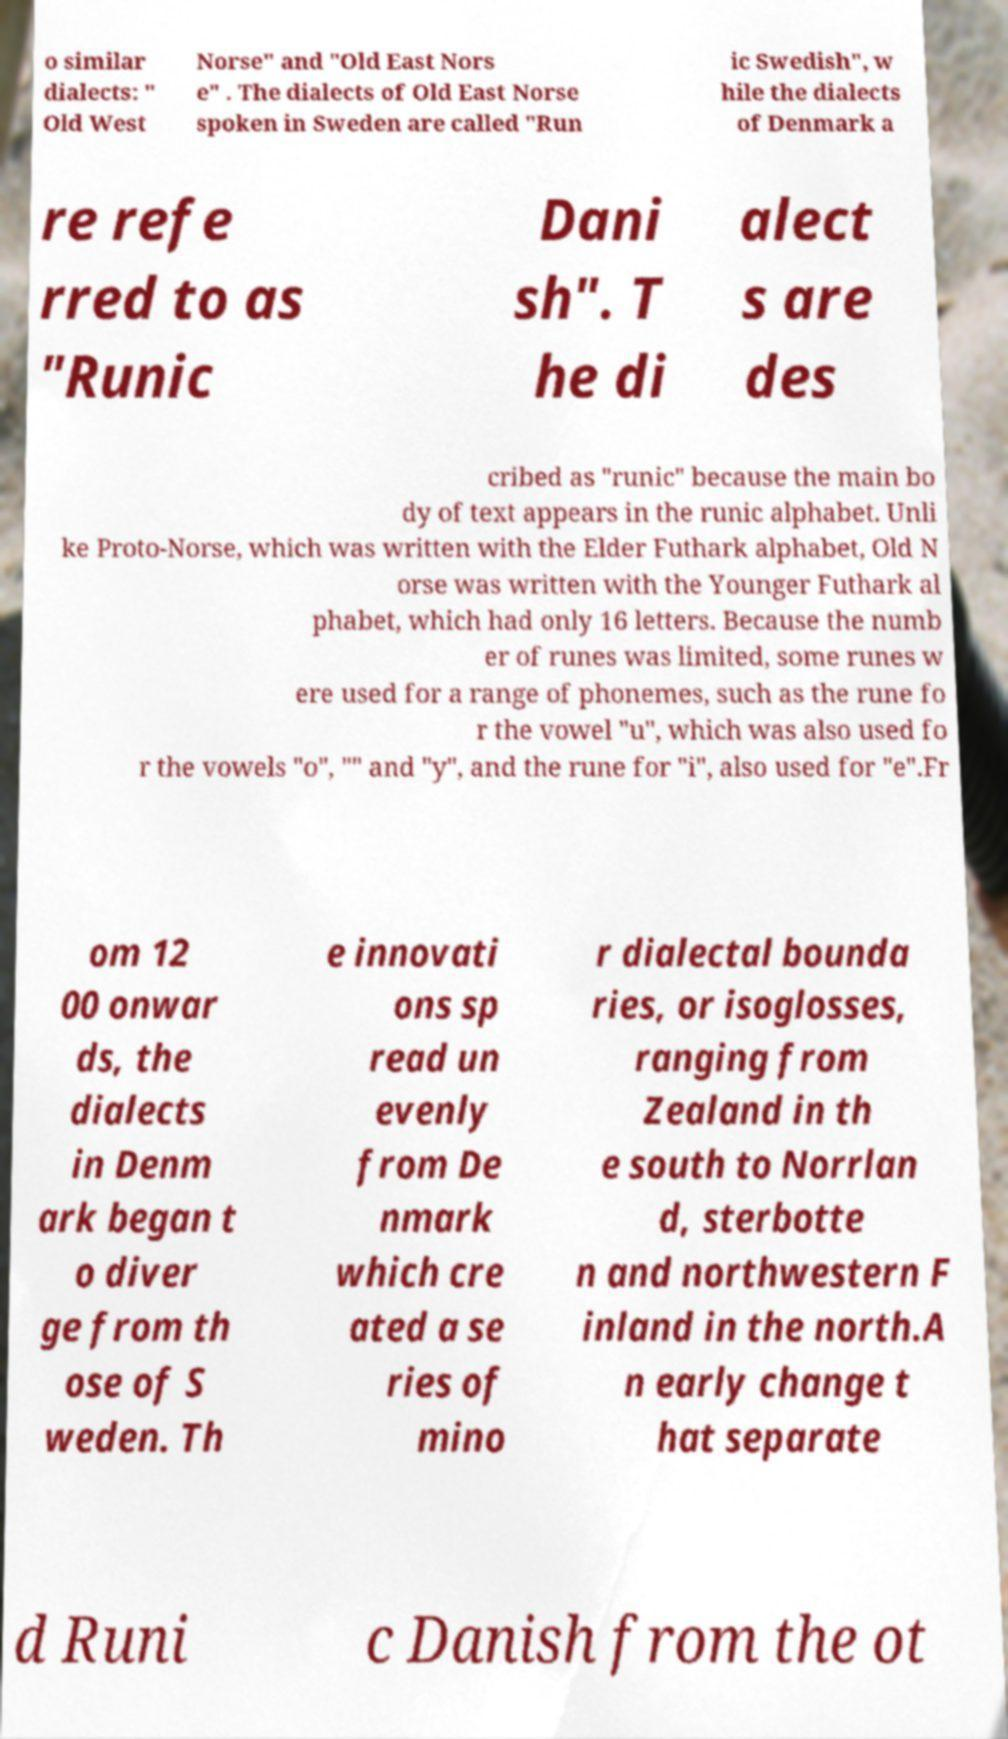For documentation purposes, I need the text within this image transcribed. Could you provide that? o similar dialects: " Old West Norse" and "Old East Nors e" . The dialects of Old East Norse spoken in Sweden are called "Run ic Swedish", w hile the dialects of Denmark a re refe rred to as "Runic Dani sh". T he di alect s are des cribed as "runic" because the main bo dy of text appears in the runic alphabet. Unli ke Proto-Norse, which was written with the Elder Futhark alphabet, Old N orse was written with the Younger Futhark al phabet, which had only 16 letters. Because the numb er of runes was limited, some runes w ere used for a range of phonemes, such as the rune fo r the vowel "u", which was also used fo r the vowels "o", "" and "y", and the rune for "i", also used for "e".Fr om 12 00 onwar ds, the dialects in Denm ark began t o diver ge from th ose of S weden. Th e innovati ons sp read un evenly from De nmark which cre ated a se ries of mino r dialectal bounda ries, or isoglosses, ranging from Zealand in th e south to Norrlan d, sterbotte n and northwestern F inland in the north.A n early change t hat separate d Runi c Danish from the ot 